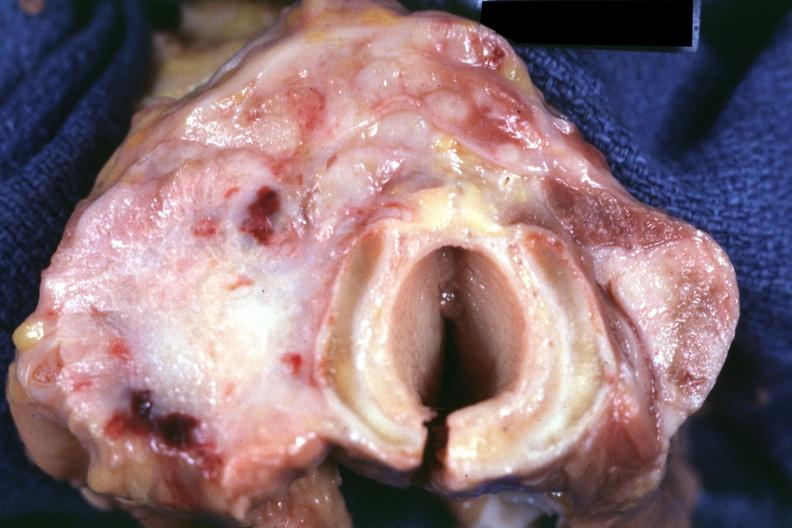what does this image show?
Answer the question using a single word or phrase. Section through thyroid and trachea apparently 